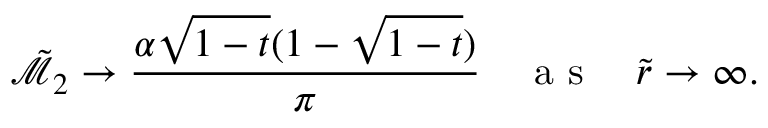Convert formula to latex. <formula><loc_0><loc_0><loc_500><loc_500>\tilde { \mathcal { M } } _ { 2 } \rightarrow \frac { \alpha \sqrt { 1 - t } ( 1 - \sqrt { 1 - t } ) } { \pi } \quad a s \quad \tilde { r } \rightarrow \infty .</formula> 